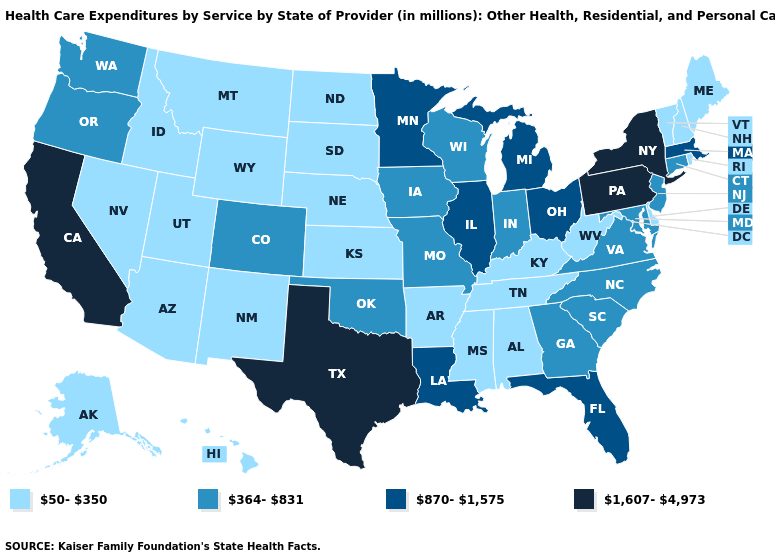Does Maine have the lowest value in the Northeast?
Give a very brief answer. Yes. Which states hav the highest value in the MidWest?
Write a very short answer. Illinois, Michigan, Minnesota, Ohio. How many symbols are there in the legend?
Short answer required. 4. What is the value of Alaska?
Write a very short answer. 50-350. What is the value of Oklahoma?
Quick response, please. 364-831. Name the states that have a value in the range 1,607-4,973?
Keep it brief. California, New York, Pennsylvania, Texas. What is the value of Illinois?
Short answer required. 870-1,575. What is the value of Utah?
Concise answer only. 50-350. What is the value of Hawaii?
Give a very brief answer. 50-350. What is the lowest value in the USA?
Short answer required. 50-350. Does Missouri have a lower value than Alaska?
Short answer required. No. What is the value of Delaware?
Quick response, please. 50-350. What is the lowest value in states that border Michigan?
Keep it brief. 364-831. Does Colorado have the lowest value in the West?
Keep it brief. No. What is the value of Nevada?
Keep it brief. 50-350. 